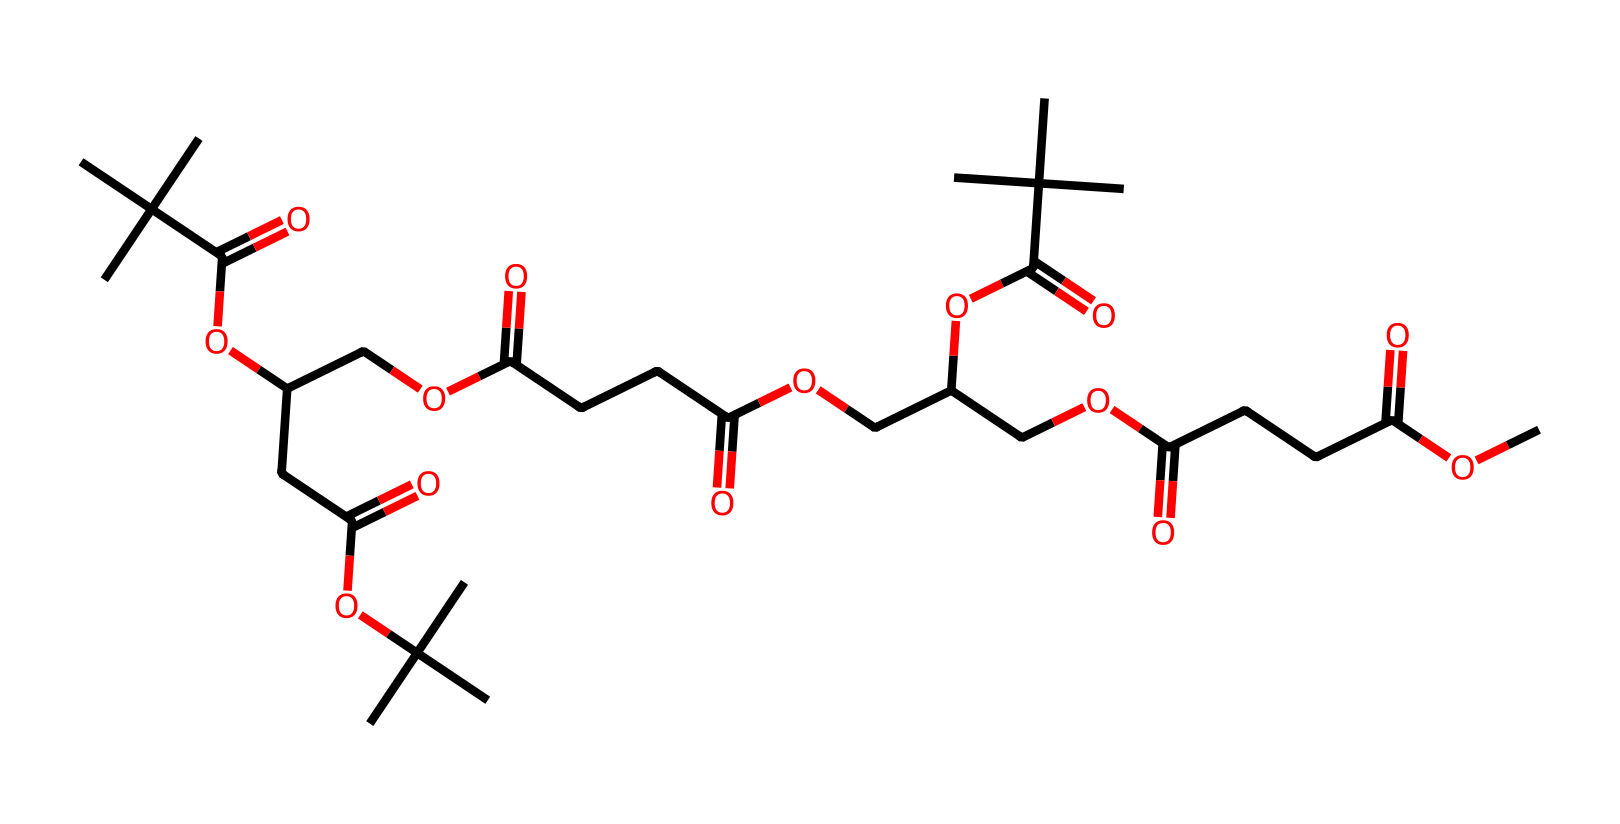What is the molecular formula derived from the SMILES representation? To derive the molecular formula, we must analyze the SMILES structure, counting the number of different atoms present (carbon, hydrogen, oxygen). From the representation, the total counts are: a certain number of carbon (C) atoms, hydrogen (H) atoms, and oxygen (O) atoms. Based on a thorough examination, the molecular formula extracted is C27H50O8.
Answer: C27H50O8 How many carbon atoms does this compound contain? By examining the SMILES representation, we count the carbon (C) atoms indicated by the presence of 'C' symbols. Accumulating these gives a total of 27 carbon atoms.
Answer: 27 What type of chemical compound is represented by this SMILES structure? Analyzing the structure, we observe that the presence of long carbon chains and ester functional groups suggest it is a lipid. Therefore, the compound is recognized as a lipid.
Answer: lipid Are there any ester functional groups in this compound? The structure reveals several occurrences of 'OC' connecting carbon chains, indicating the presence of ester bonds. Thus, it can be concluded that ester functional groups exist in this compound.
Answer: yes What role do the abundant carbon chains play in its lubricating properties? The long carbon chains contribute to reducing friction between surfaces by providing a smooth, hydrophobic layer, effectively enhancing lubricating properties. This structure helps in forming a protective film that minimizes wear and tear.
Answer: reduces friction How does this compound's biodegradability enhance its eco-friendly aspect? The biodegradability arises from its natural lipid composition and hydrocarbon structure, which microorganisms can metabolize, thus minimizing environmental impact and making it environmentally safe.
Answer: environmentally safe 